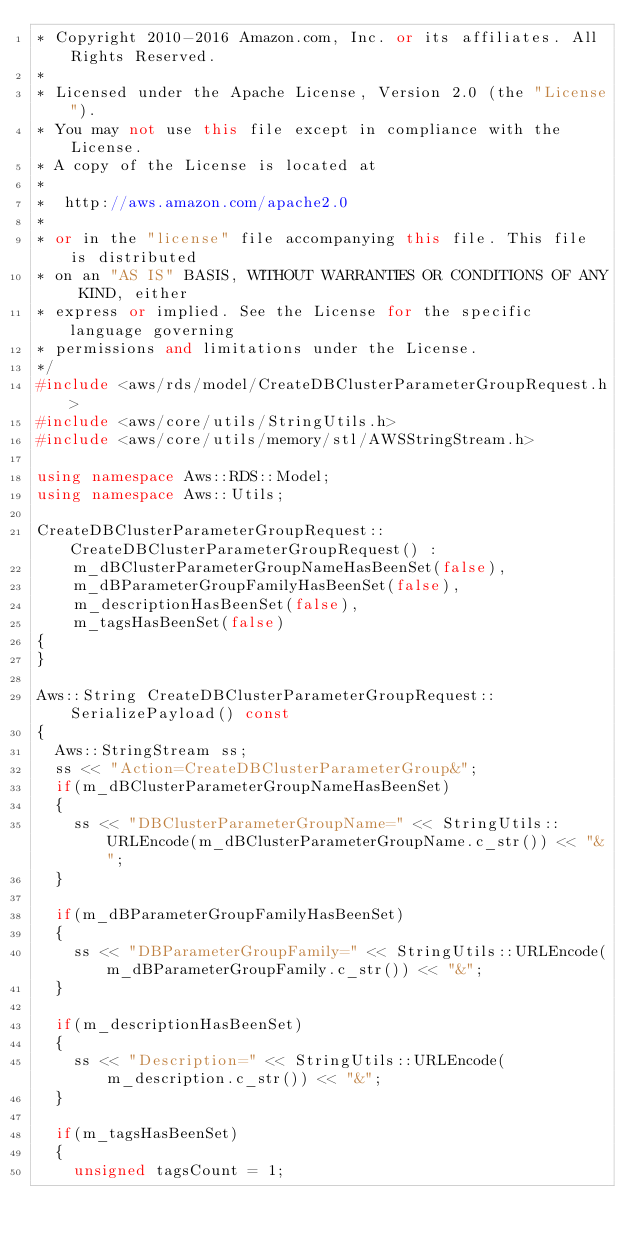<code> <loc_0><loc_0><loc_500><loc_500><_C++_>* Copyright 2010-2016 Amazon.com, Inc. or its affiliates. All Rights Reserved.
*
* Licensed under the Apache License, Version 2.0 (the "License").
* You may not use this file except in compliance with the License.
* A copy of the License is located at
*
*  http://aws.amazon.com/apache2.0
*
* or in the "license" file accompanying this file. This file is distributed
* on an "AS IS" BASIS, WITHOUT WARRANTIES OR CONDITIONS OF ANY KIND, either
* express or implied. See the License for the specific language governing
* permissions and limitations under the License.
*/
#include <aws/rds/model/CreateDBClusterParameterGroupRequest.h>
#include <aws/core/utils/StringUtils.h>
#include <aws/core/utils/memory/stl/AWSStringStream.h>

using namespace Aws::RDS::Model;
using namespace Aws::Utils;

CreateDBClusterParameterGroupRequest::CreateDBClusterParameterGroupRequest() : 
    m_dBClusterParameterGroupNameHasBeenSet(false),
    m_dBParameterGroupFamilyHasBeenSet(false),
    m_descriptionHasBeenSet(false),
    m_tagsHasBeenSet(false)
{
}

Aws::String CreateDBClusterParameterGroupRequest::SerializePayload() const
{
  Aws::StringStream ss;
  ss << "Action=CreateDBClusterParameterGroup&";
  if(m_dBClusterParameterGroupNameHasBeenSet)
  {
    ss << "DBClusterParameterGroupName=" << StringUtils::URLEncode(m_dBClusterParameterGroupName.c_str()) << "&";
  }

  if(m_dBParameterGroupFamilyHasBeenSet)
  {
    ss << "DBParameterGroupFamily=" << StringUtils::URLEncode(m_dBParameterGroupFamily.c_str()) << "&";
  }

  if(m_descriptionHasBeenSet)
  {
    ss << "Description=" << StringUtils::URLEncode(m_description.c_str()) << "&";
  }

  if(m_tagsHasBeenSet)
  {
    unsigned tagsCount = 1;</code> 